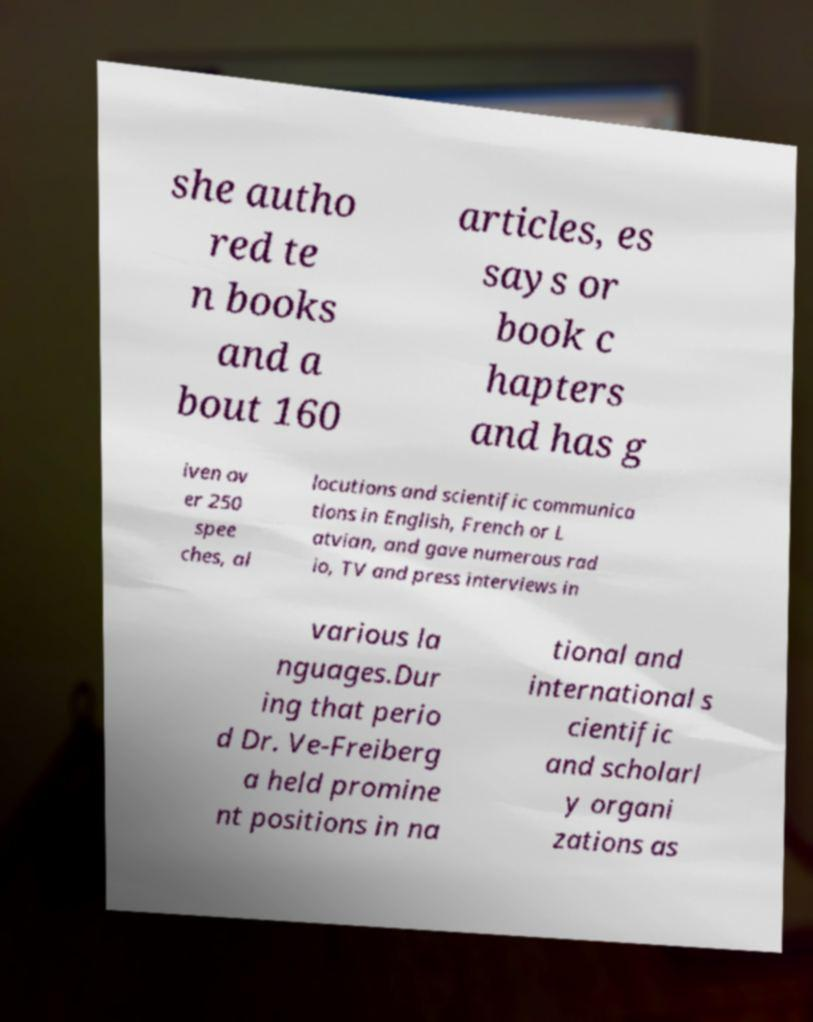Could you extract and type out the text from this image? she autho red te n books and a bout 160 articles, es says or book c hapters and has g iven ov er 250 spee ches, al locutions and scientific communica tions in English, French or L atvian, and gave numerous rad io, TV and press interviews in various la nguages.Dur ing that perio d Dr. Ve-Freiberg a held promine nt positions in na tional and international s cientific and scholarl y organi zations as 